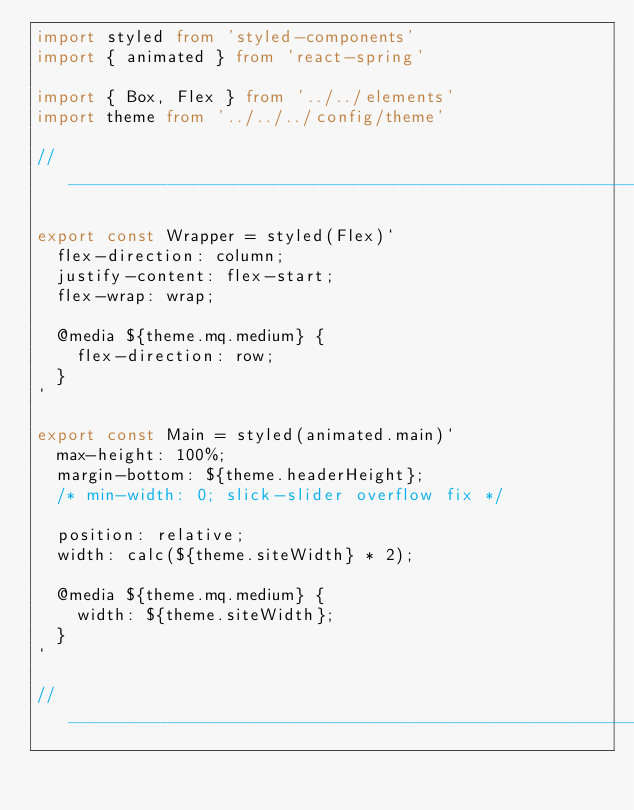<code> <loc_0><loc_0><loc_500><loc_500><_TypeScript_>import styled from 'styled-components'
import { animated } from 'react-spring'

import { Box, Flex } from '../../elements'
import theme from '../../../config/theme'

// ___________________________________________________________________

export const Wrapper = styled(Flex)`
  flex-direction: column;
  justify-content: flex-start;
  flex-wrap: wrap;

  @media ${theme.mq.medium} {
    flex-direction: row;
  }
`

export const Main = styled(animated.main)`
  max-height: 100%;
  margin-bottom: ${theme.headerHeight};
  /* min-width: 0; slick-slider overflow fix */

  position: relative;
  width: calc(${theme.siteWidth} * 2);

  @media ${theme.mq.medium} {
    width: ${theme.siteWidth};
  }
`

// ___________________________________________________________________
</code> 